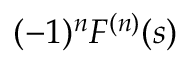Convert formula to latex. <formula><loc_0><loc_0><loc_500><loc_500>( - 1 ) ^ { n } F ^ { ( n ) } ( s )</formula> 